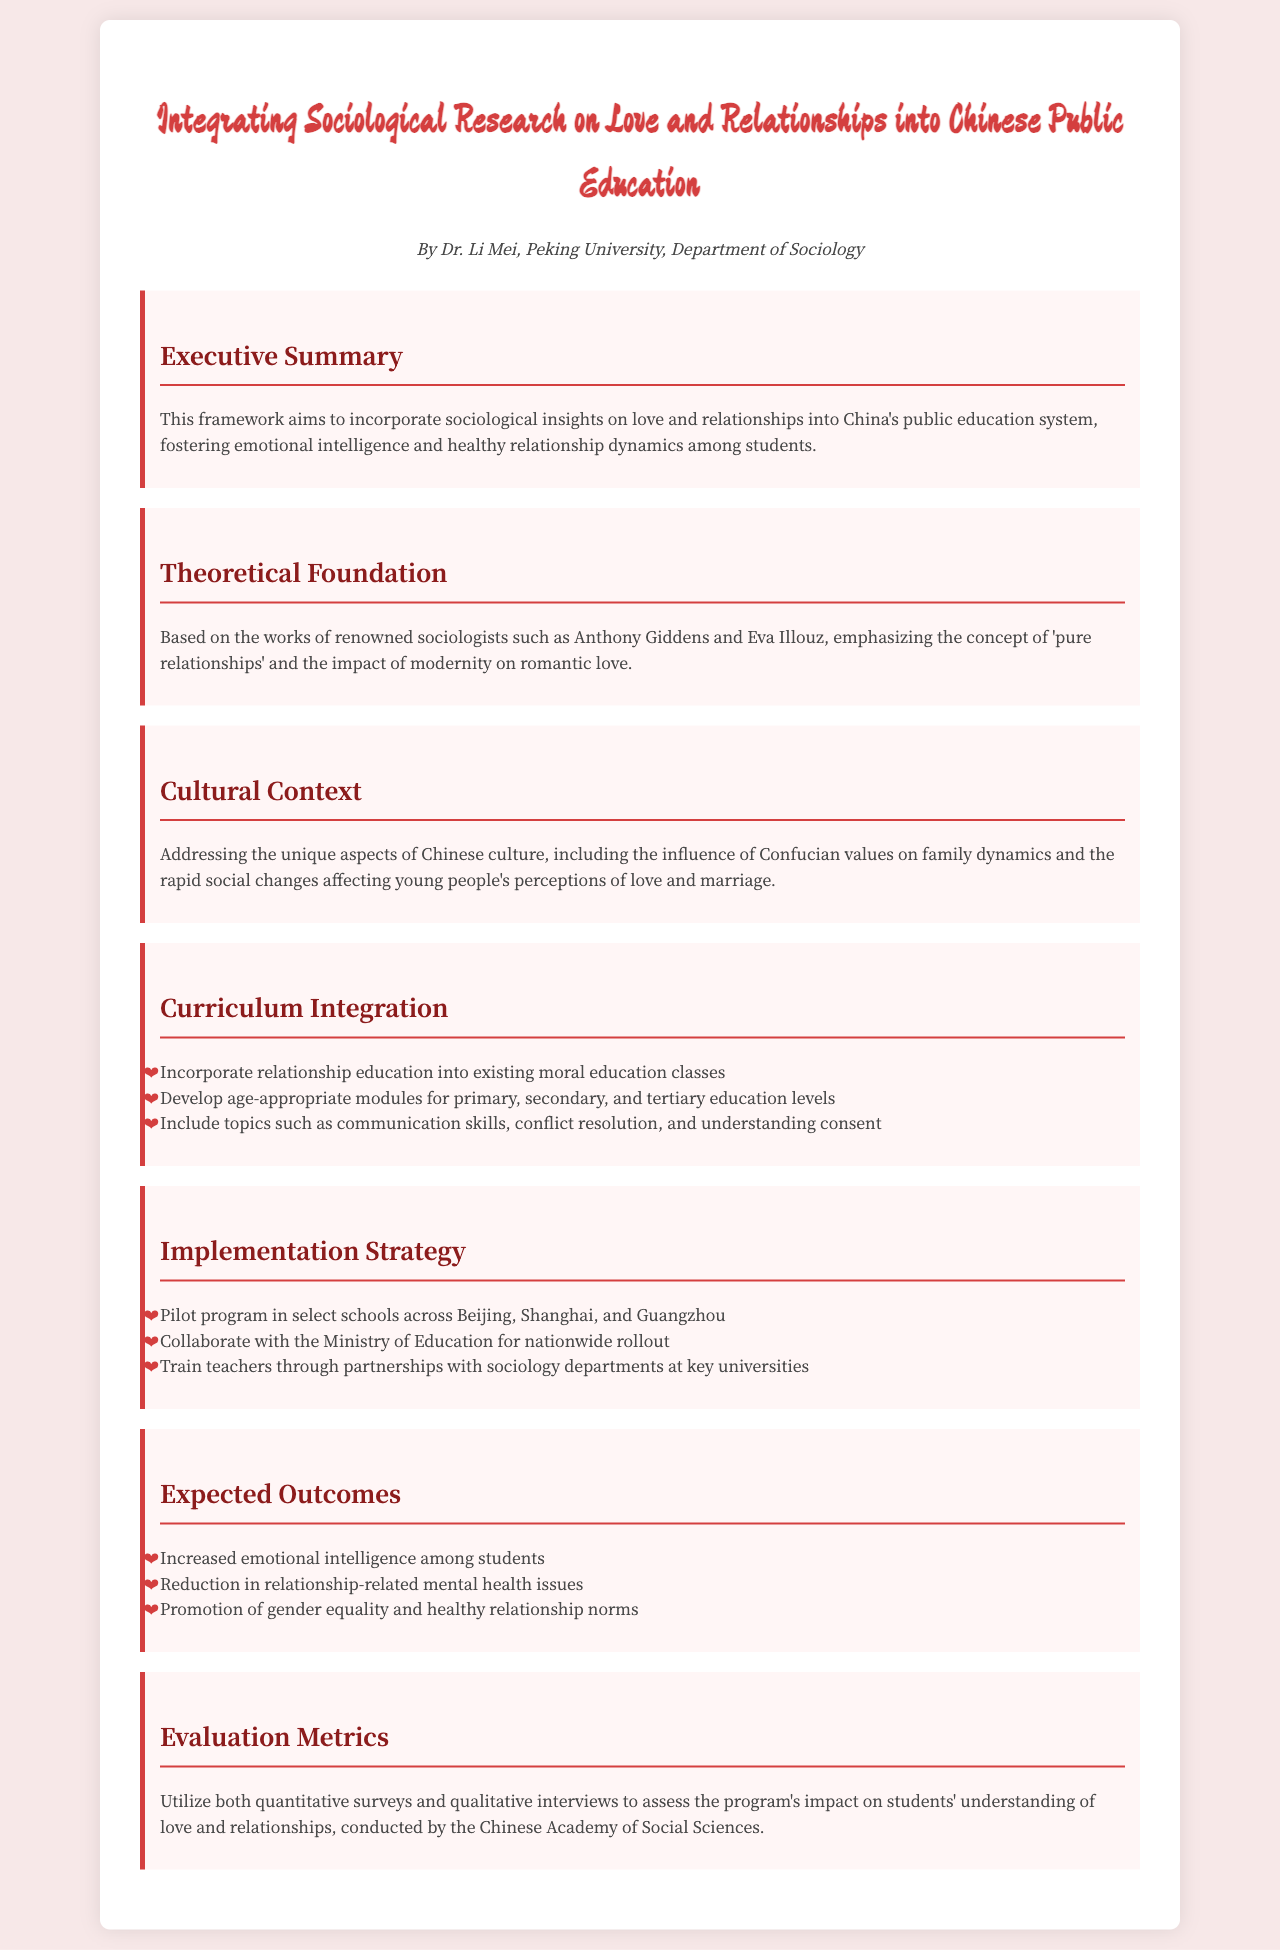What is the title of the document? The title is prominently displayed at the top of the document, introducing the main topic.
Answer: Integrating Sociological Research on Love and Relationships into Chinese Public Education Who is the author of the document? The author is mentioned below the title, indicating the responsible individual for the content.
Answer: Dr. Li Mei What concept is emphasized in the theoretical foundation? The document lists key concepts that are essential to the framework, highlighting sociological theories relevant to love and relationships.
Answer: Pure relationships What age levels are targeted for the curriculum integration? The document specifies the educational stages that will feature the new curriculum modules.
Answer: Primary, secondary, and tertiary education levels Which cities are mentioned for the pilot program implementation? The document identifies specific cities to initiate the pilot program as part of the implementation strategy.
Answer: Beijing, Shanghai, and Guangzhou What is one expected outcome of the program? The document outlines anticipated results from the implementation of the framework, reflecting the goals of the initiative.
Answer: Increased emotional intelligence among students Which organization will conduct the evaluation metrics? The document states the responsible body for evaluating the impact of the program on students.
Answer: Chinese Academy of Social Sciences What aspect of culture does the document address? The document discusses a specific cultural framework that informs the approach taken within the curriculum integration.
Answer: Confucian values 